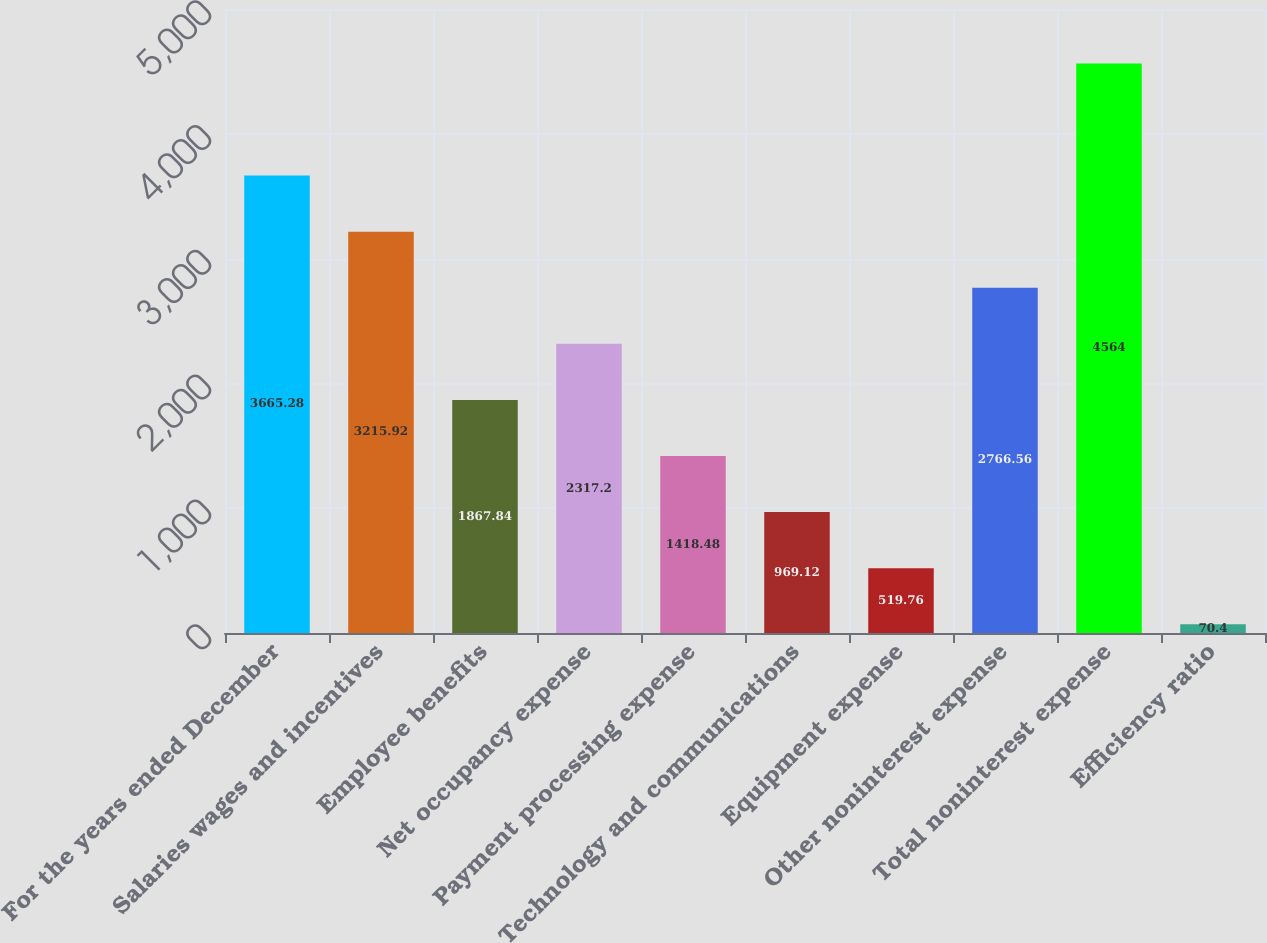Convert chart. <chart><loc_0><loc_0><loc_500><loc_500><bar_chart><fcel>For the years ended December<fcel>Salaries wages and incentives<fcel>Employee benefits<fcel>Net occupancy expense<fcel>Payment processing expense<fcel>Technology and communications<fcel>Equipment expense<fcel>Other noninterest expense<fcel>Total noninterest expense<fcel>Efficiency ratio<nl><fcel>3665.28<fcel>3215.92<fcel>1867.84<fcel>2317.2<fcel>1418.48<fcel>969.12<fcel>519.76<fcel>2766.56<fcel>4564<fcel>70.4<nl></chart> 